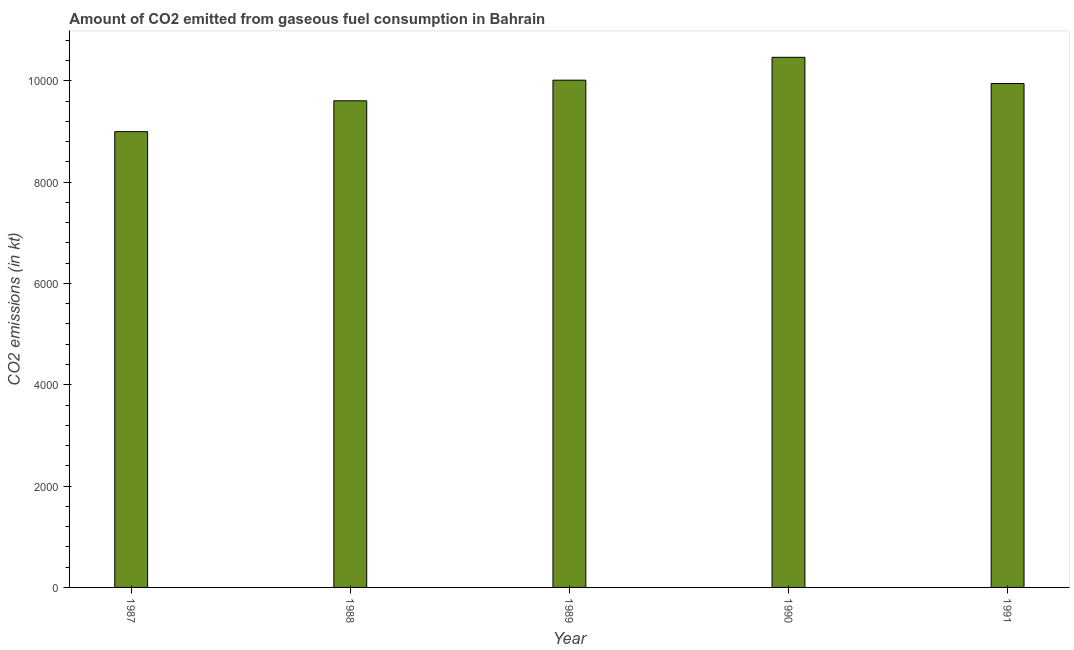Does the graph contain grids?
Your response must be concise. No. What is the title of the graph?
Offer a terse response. Amount of CO2 emitted from gaseous fuel consumption in Bahrain. What is the label or title of the Y-axis?
Keep it short and to the point. CO2 emissions (in kt). What is the co2 emissions from gaseous fuel consumption in 1987?
Offer a very short reply. 8995.15. Across all years, what is the maximum co2 emissions from gaseous fuel consumption?
Ensure brevity in your answer.  1.05e+04. Across all years, what is the minimum co2 emissions from gaseous fuel consumption?
Ensure brevity in your answer.  8995.15. In which year was the co2 emissions from gaseous fuel consumption maximum?
Provide a short and direct response. 1990. What is the sum of the co2 emissions from gaseous fuel consumption?
Offer a very short reply. 4.90e+04. What is the difference between the co2 emissions from gaseous fuel consumption in 1988 and 1991?
Ensure brevity in your answer.  -341.03. What is the average co2 emissions from gaseous fuel consumption per year?
Make the answer very short. 9803.36. What is the median co2 emissions from gaseous fuel consumption?
Provide a succinct answer. 9944.9. Do a majority of the years between 1991 and 1990 (inclusive) have co2 emissions from gaseous fuel consumption greater than 9600 kt?
Provide a succinct answer. No. Is the co2 emissions from gaseous fuel consumption in 1987 less than that in 1989?
Give a very brief answer. Yes. What is the difference between the highest and the second highest co2 emissions from gaseous fuel consumption?
Offer a very short reply. 451.04. What is the difference between the highest and the lowest co2 emissions from gaseous fuel consumption?
Make the answer very short. 1466.8. In how many years, is the co2 emissions from gaseous fuel consumption greater than the average co2 emissions from gaseous fuel consumption taken over all years?
Your response must be concise. 3. How many bars are there?
Your response must be concise. 5. Are the values on the major ticks of Y-axis written in scientific E-notation?
Offer a terse response. No. What is the CO2 emissions (in kt) of 1987?
Offer a terse response. 8995.15. What is the CO2 emissions (in kt) in 1988?
Offer a very short reply. 9603.87. What is the CO2 emissions (in kt) of 1989?
Give a very brief answer. 1.00e+04. What is the CO2 emissions (in kt) in 1990?
Your response must be concise. 1.05e+04. What is the CO2 emissions (in kt) of 1991?
Ensure brevity in your answer.  9944.9. What is the difference between the CO2 emissions (in kt) in 1987 and 1988?
Make the answer very short. -608.72. What is the difference between the CO2 emissions (in kt) in 1987 and 1989?
Offer a terse response. -1015.76. What is the difference between the CO2 emissions (in kt) in 1987 and 1990?
Provide a short and direct response. -1466.8. What is the difference between the CO2 emissions (in kt) in 1987 and 1991?
Your answer should be compact. -949.75. What is the difference between the CO2 emissions (in kt) in 1988 and 1989?
Keep it short and to the point. -407.04. What is the difference between the CO2 emissions (in kt) in 1988 and 1990?
Give a very brief answer. -858.08. What is the difference between the CO2 emissions (in kt) in 1988 and 1991?
Give a very brief answer. -341.03. What is the difference between the CO2 emissions (in kt) in 1989 and 1990?
Provide a short and direct response. -451.04. What is the difference between the CO2 emissions (in kt) in 1989 and 1991?
Provide a short and direct response. 66.01. What is the difference between the CO2 emissions (in kt) in 1990 and 1991?
Your response must be concise. 517.05. What is the ratio of the CO2 emissions (in kt) in 1987 to that in 1988?
Offer a terse response. 0.94. What is the ratio of the CO2 emissions (in kt) in 1987 to that in 1989?
Your response must be concise. 0.9. What is the ratio of the CO2 emissions (in kt) in 1987 to that in 1990?
Give a very brief answer. 0.86. What is the ratio of the CO2 emissions (in kt) in 1987 to that in 1991?
Your response must be concise. 0.9. What is the ratio of the CO2 emissions (in kt) in 1988 to that in 1989?
Offer a terse response. 0.96. What is the ratio of the CO2 emissions (in kt) in 1988 to that in 1990?
Give a very brief answer. 0.92. What is the ratio of the CO2 emissions (in kt) in 1989 to that in 1991?
Ensure brevity in your answer.  1.01. What is the ratio of the CO2 emissions (in kt) in 1990 to that in 1991?
Provide a short and direct response. 1.05. 